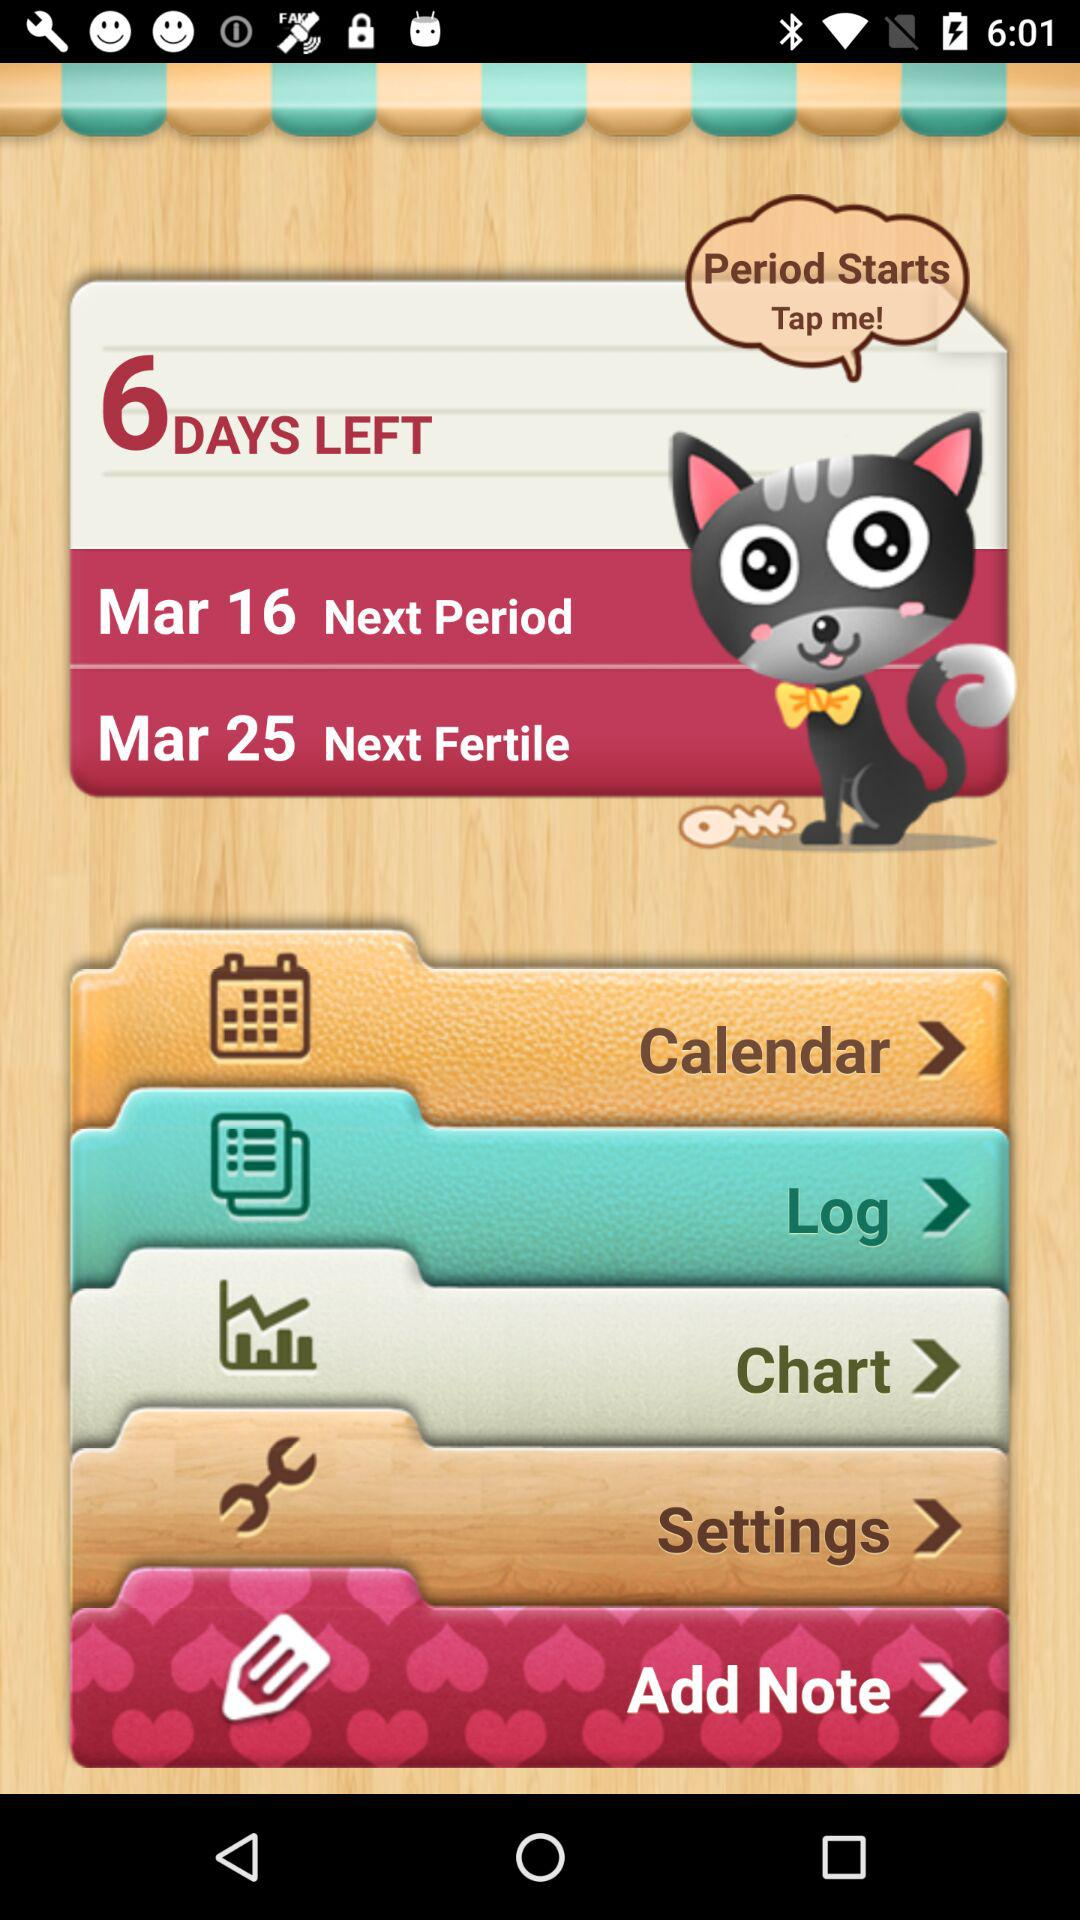How many days are left? The number of days left is 6. 